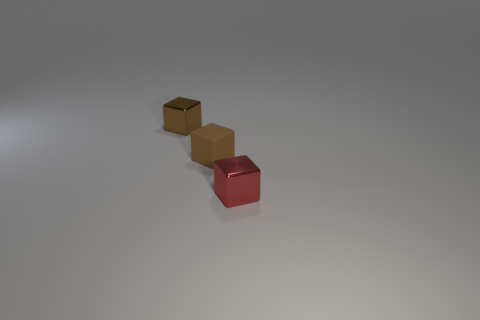Subtract all tiny metal blocks. How many blocks are left? 1 Add 2 red things. How many objects exist? 5 Subtract all brown cubes. How many cubes are left? 1 Subtract 3 blocks. How many blocks are left? 0 Subtract all red cubes. Subtract all cyan cylinders. How many cubes are left? 2 Subtract all cyan spheres. How many brown cubes are left? 2 Subtract all matte things. Subtract all brown matte things. How many objects are left? 1 Add 2 brown shiny cubes. How many brown shiny cubes are left? 3 Add 2 tiny green matte blocks. How many tiny green matte blocks exist? 2 Subtract 0 gray blocks. How many objects are left? 3 